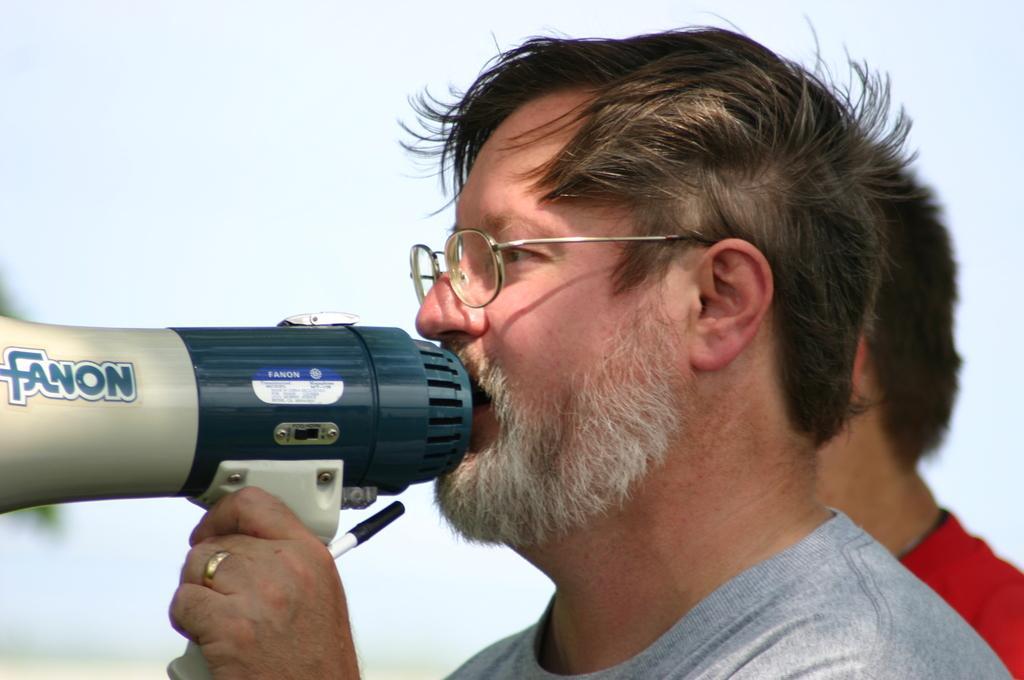Can you describe this image briefly? In this picture we can observe a person wearing spectacles and a T shirt, holding a speaker in his hand. Behind him there is another person wearing red color T shirt. In the background there is a sky. 